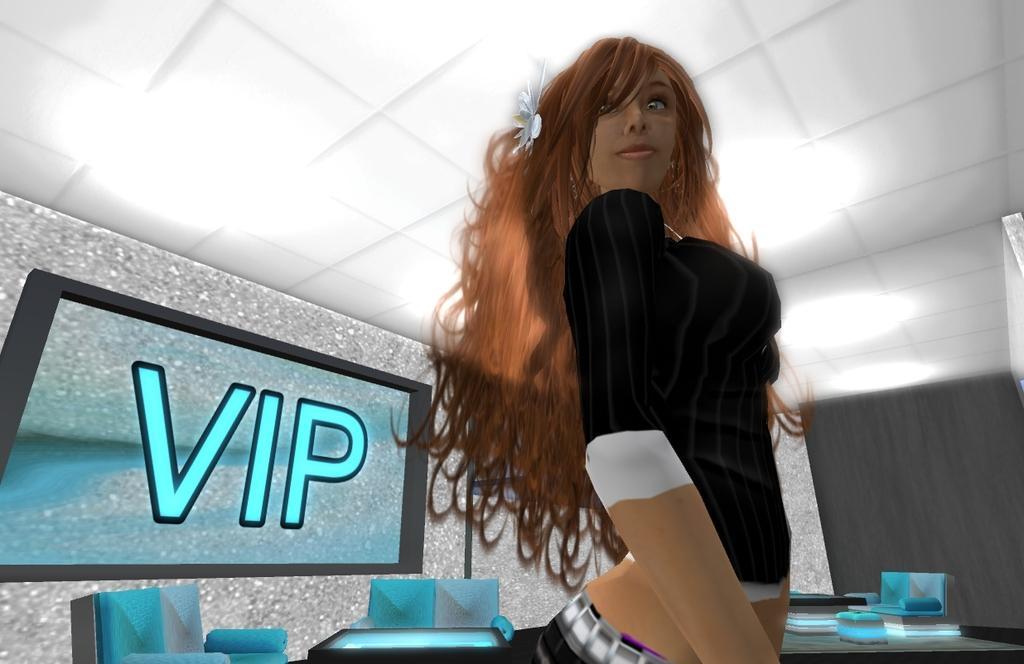Please provide a concise description of this image. It is an animated image. In this image I can see a girl, television, wall, chairs, tables, ceiling and objects. Something is written on the screen.   